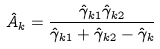<formula> <loc_0><loc_0><loc_500><loc_500>\hat { A } _ { k } = \frac { \hat { \gamma } _ { k 1 } \hat { \gamma } _ { k 2 } } { \hat { \gamma } _ { k 1 } + \hat { \gamma } _ { k 2 } - \hat { \gamma } _ { k } }</formula> 